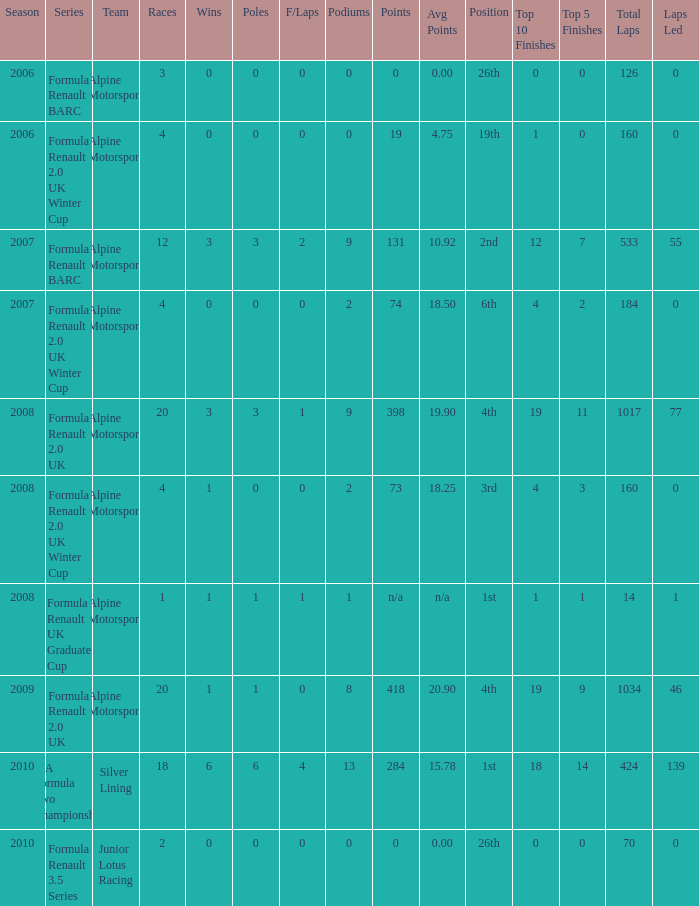What was the earliest season where podium was 9? 2007.0. 